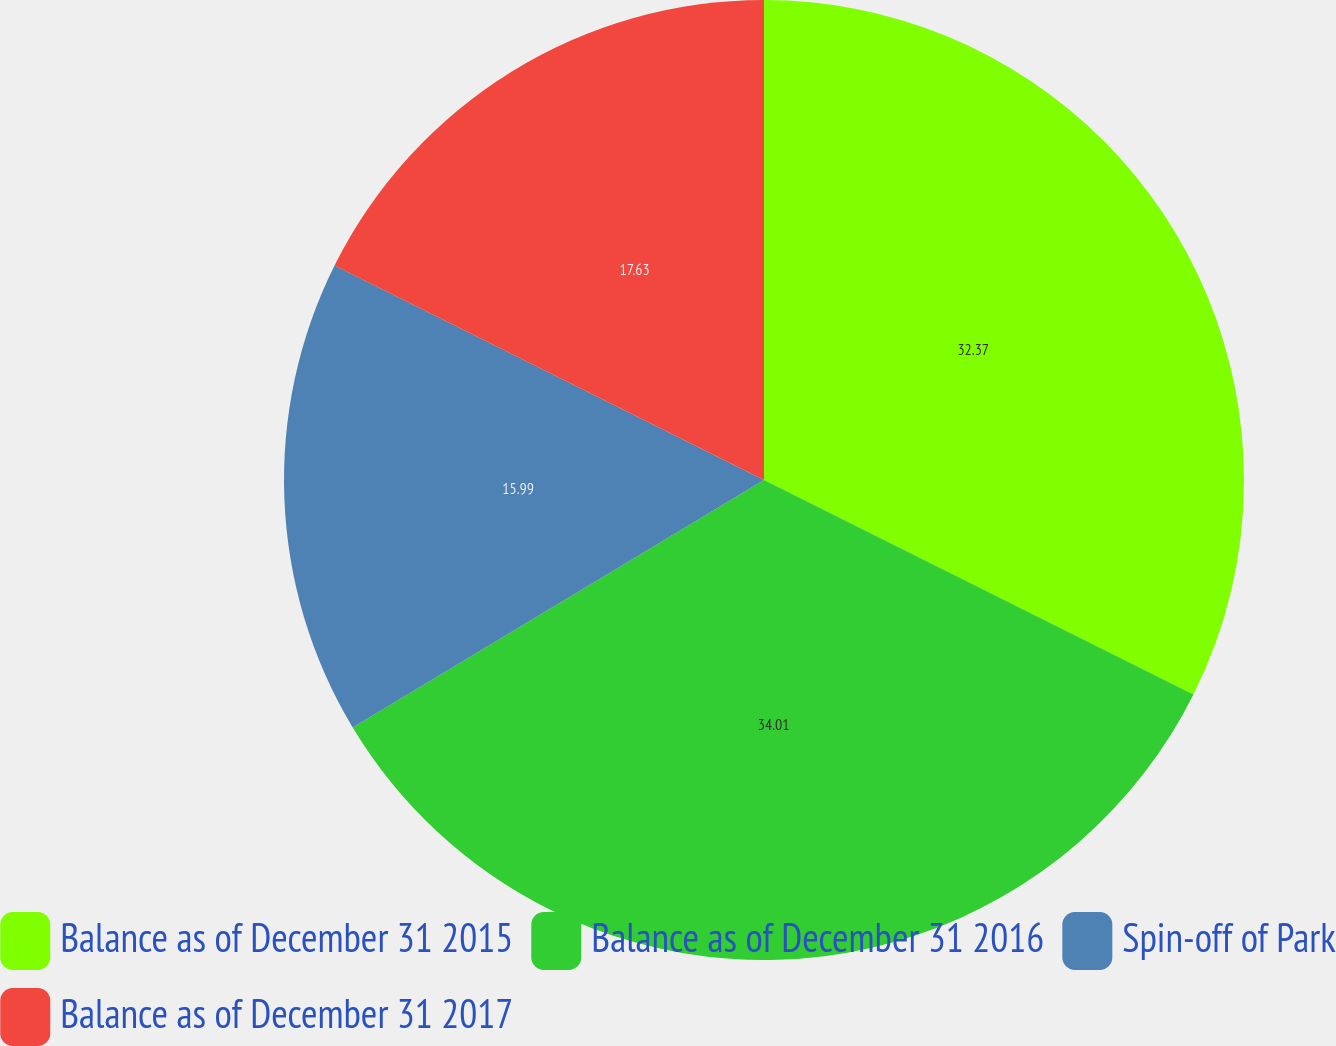<chart> <loc_0><loc_0><loc_500><loc_500><pie_chart><fcel>Balance as of December 31 2015<fcel>Balance as of December 31 2016<fcel>Spin-off of Park<fcel>Balance as of December 31 2017<nl><fcel>32.37%<fcel>34.01%<fcel>15.99%<fcel>17.63%<nl></chart> 